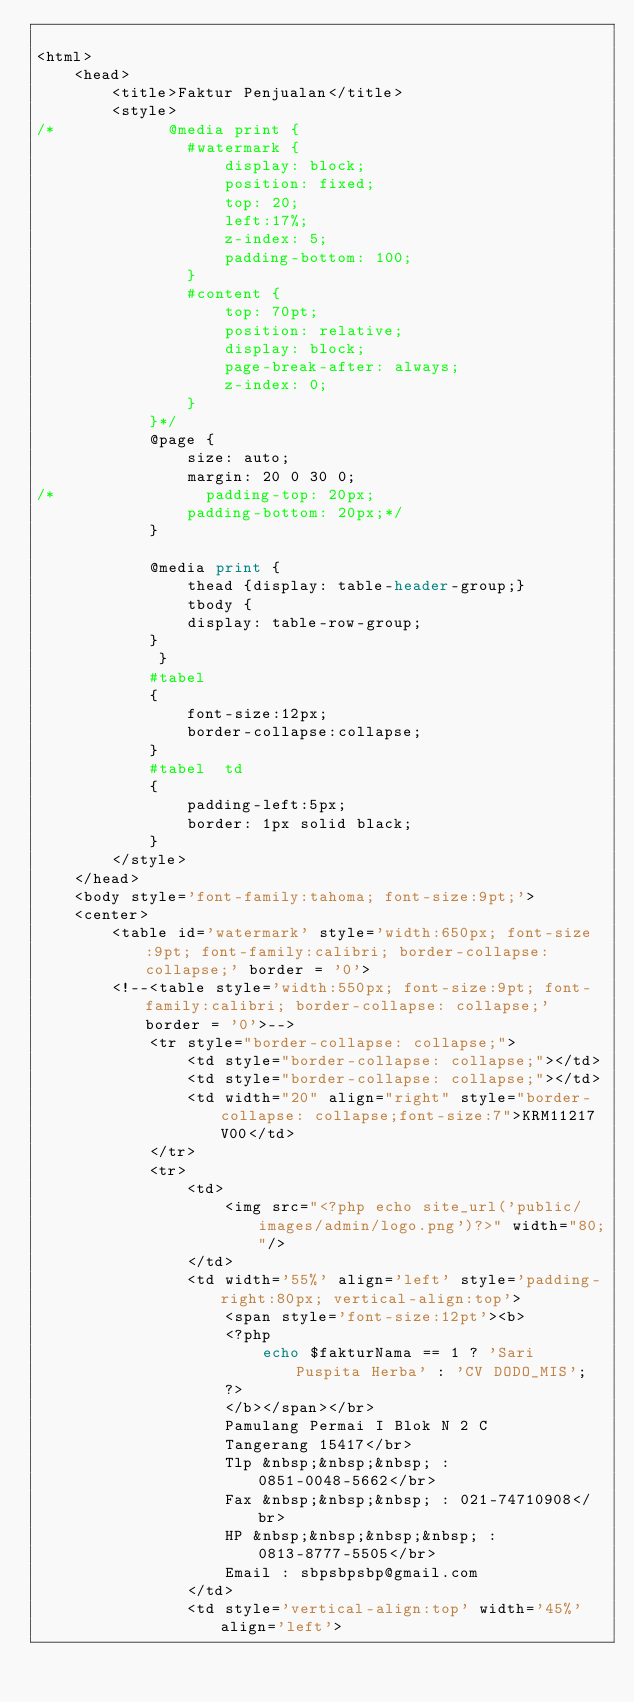<code> <loc_0><loc_0><loc_500><loc_500><_PHP_>
<html>
    <head>
        <title>Faktur Penjualan</title>
        <style>
/*            @media print {
                #watermark { 
                    display: block;
                    position: fixed;
                    top: 20;
                    left:17%;
                    z-index: 5;
                    padding-bottom: 100;
                }
                #content { 
                    top: 70pt;
                    position: relative;
                    display: block;
                    page-break-after: always;
                    z-index: 0;
                }
            }*/
            @page {
                size: auto;  
                margin: 20 0 30 0; 
/*                padding-top: 20px;
                padding-bottom: 20px;*/
            }
            
            @media print {
                thead {display: table-header-group;}
                tbody {
                display: table-row-group;
            }
             }
            #tabel
            {
                font-size:12px;
                border-collapse:collapse;
            }
            #tabel  td
            {
                padding-left:5px;
                border: 1px solid black;
            }
        </style>    
    </head>
    <body style='font-family:tahoma; font-size:9pt;'>
    <center>
        <table id='watermark' style='width:650px; font-size:9pt; font-family:calibri; border-collapse: collapse;' border = '0'>
        <!--<table style='width:550px; font-size:9pt; font-family:calibri; border-collapse: collapse;' border = '0'>-->
            <tr style="border-collapse: collapse;">
                <td style="border-collapse: collapse;"></td>
                <td style="border-collapse: collapse;"></td>
                <td width="20" align="right" style="border-collapse: collapse;font-size:7">KRM11217 V00</td>
            </tr>
            <tr>
                <td>
                    <img src="<?php echo site_url('public/images/admin/logo.png')?>" width="80;"/>
                </td>
                <td width='55%' align='left' style='padding-right:80px; vertical-align:top'>
                    <span style='font-size:12pt'><b>
                    <?php
                        echo $fakturNama == 1 ? 'Sari Puspita Herba' : 'CV DODO_MIS';
                    ?>
                    </b></span></br>
                    Pamulang Permai I Blok N 2 C 
                    Tangerang 15417</br>
                    Tlp &nbsp;&nbsp;&nbsp; : 0851-0048-5662</br>
                    Fax &nbsp;&nbsp;&nbsp; : 021-74710908</br>
                    HP &nbsp;&nbsp;&nbsp;&nbsp; : 0813-8777-5505</br>
                    Email : sbpsbpsbp@gmail.com
                </td>
                <td style='vertical-align:top' width='45%' align='left'></code> 